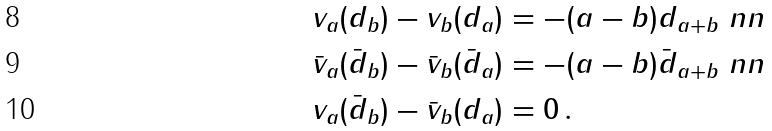<formula> <loc_0><loc_0><loc_500><loc_500>& v _ { a } ( d _ { b } ) - v _ { b } ( d _ { a } ) = - ( a - b ) d _ { a + b } \ n n \\ & \bar { v } _ { a } ( \bar { d } _ { b } ) - \bar { v } _ { b } ( \bar { d } _ { a } ) = - ( a - b ) \bar { d } _ { a + b } \ n n \\ & v _ { a } ( \bar { d } _ { b } ) - \bar { v } _ { b } ( d _ { a } ) = 0 \, .</formula> 